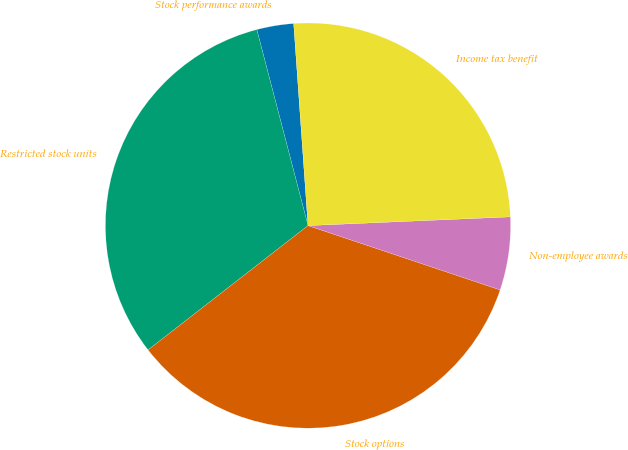Convert chart. <chart><loc_0><loc_0><loc_500><loc_500><pie_chart><fcel>Stock performance awards<fcel>Restricted stock units<fcel>Stock options<fcel>Non-employee awards<fcel>Income tax benefit<nl><fcel>2.94%<fcel>31.45%<fcel>34.34%<fcel>5.83%<fcel>25.44%<nl></chart> 